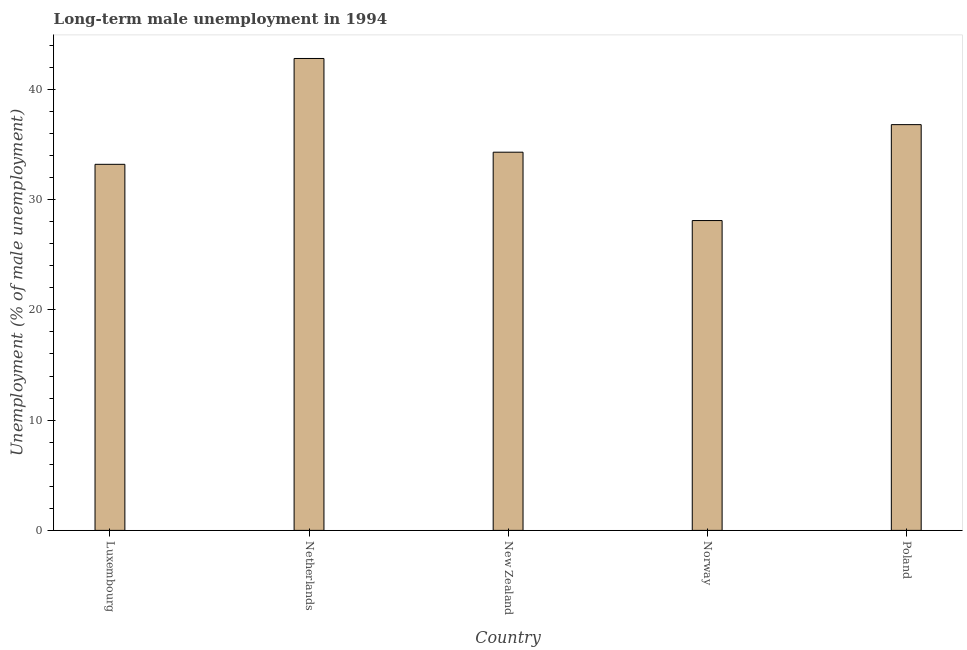Does the graph contain any zero values?
Make the answer very short. No. What is the title of the graph?
Provide a short and direct response. Long-term male unemployment in 1994. What is the label or title of the Y-axis?
Offer a very short reply. Unemployment (% of male unemployment). What is the long-term male unemployment in New Zealand?
Provide a succinct answer. 34.3. Across all countries, what is the maximum long-term male unemployment?
Your response must be concise. 42.8. Across all countries, what is the minimum long-term male unemployment?
Offer a very short reply. 28.1. In which country was the long-term male unemployment minimum?
Give a very brief answer. Norway. What is the sum of the long-term male unemployment?
Give a very brief answer. 175.2. What is the difference between the long-term male unemployment in Norway and Poland?
Keep it short and to the point. -8.7. What is the average long-term male unemployment per country?
Provide a succinct answer. 35.04. What is the median long-term male unemployment?
Keep it short and to the point. 34.3. In how many countries, is the long-term male unemployment greater than 32 %?
Make the answer very short. 4. What is the ratio of the long-term male unemployment in Netherlands to that in Poland?
Provide a succinct answer. 1.16. What is the difference between the highest and the second highest long-term male unemployment?
Ensure brevity in your answer.  6. In how many countries, is the long-term male unemployment greater than the average long-term male unemployment taken over all countries?
Make the answer very short. 2. How many bars are there?
Keep it short and to the point. 5. Are all the bars in the graph horizontal?
Make the answer very short. No. Are the values on the major ticks of Y-axis written in scientific E-notation?
Make the answer very short. No. What is the Unemployment (% of male unemployment) in Luxembourg?
Keep it short and to the point. 33.2. What is the Unemployment (% of male unemployment) in Netherlands?
Your answer should be compact. 42.8. What is the Unemployment (% of male unemployment) of New Zealand?
Your response must be concise. 34.3. What is the Unemployment (% of male unemployment) of Norway?
Offer a very short reply. 28.1. What is the Unemployment (% of male unemployment) in Poland?
Provide a short and direct response. 36.8. What is the difference between the Unemployment (% of male unemployment) in Luxembourg and New Zealand?
Give a very brief answer. -1.1. What is the difference between the Unemployment (% of male unemployment) in Luxembourg and Norway?
Your response must be concise. 5.1. What is the difference between the Unemployment (% of male unemployment) in Netherlands and New Zealand?
Keep it short and to the point. 8.5. What is the difference between the Unemployment (% of male unemployment) in Netherlands and Poland?
Keep it short and to the point. 6. What is the difference between the Unemployment (% of male unemployment) in New Zealand and Norway?
Provide a succinct answer. 6.2. What is the difference between the Unemployment (% of male unemployment) in Norway and Poland?
Give a very brief answer. -8.7. What is the ratio of the Unemployment (% of male unemployment) in Luxembourg to that in Netherlands?
Offer a terse response. 0.78. What is the ratio of the Unemployment (% of male unemployment) in Luxembourg to that in Norway?
Your answer should be compact. 1.18. What is the ratio of the Unemployment (% of male unemployment) in Luxembourg to that in Poland?
Your response must be concise. 0.9. What is the ratio of the Unemployment (% of male unemployment) in Netherlands to that in New Zealand?
Keep it short and to the point. 1.25. What is the ratio of the Unemployment (% of male unemployment) in Netherlands to that in Norway?
Offer a terse response. 1.52. What is the ratio of the Unemployment (% of male unemployment) in Netherlands to that in Poland?
Offer a very short reply. 1.16. What is the ratio of the Unemployment (% of male unemployment) in New Zealand to that in Norway?
Keep it short and to the point. 1.22. What is the ratio of the Unemployment (% of male unemployment) in New Zealand to that in Poland?
Provide a succinct answer. 0.93. What is the ratio of the Unemployment (% of male unemployment) in Norway to that in Poland?
Make the answer very short. 0.76. 